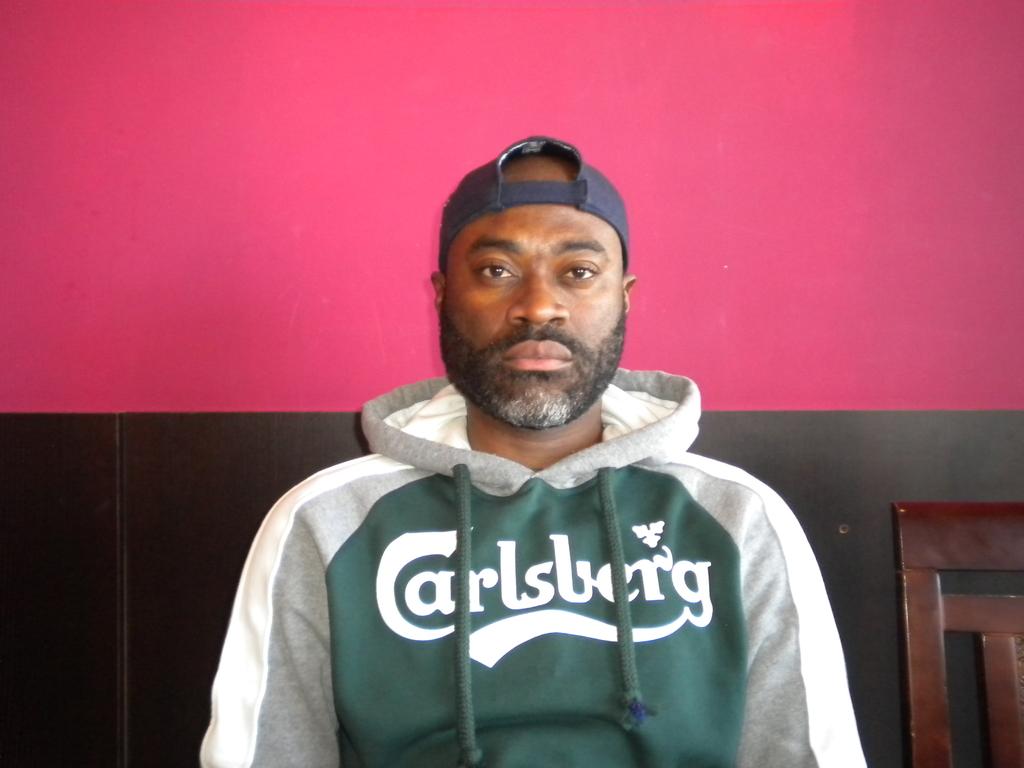Which city is on the hoodie?
Your response must be concise. Carlsberg. 